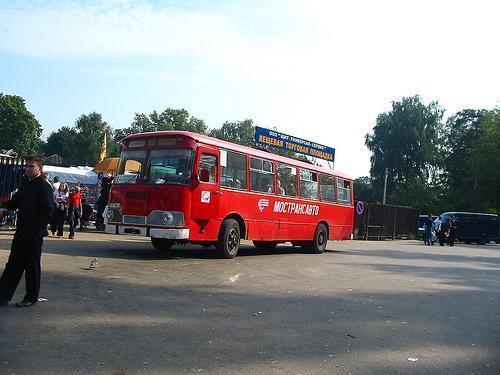How many people are standing to the right of the bus?
Give a very brief answer. 5. 